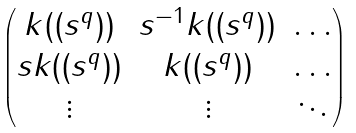Convert formula to latex. <formula><loc_0><loc_0><loc_500><loc_500>\begin{pmatrix} k ( ( s ^ { q } ) ) & s ^ { - 1 } k ( ( s ^ { q } ) ) & \hdots \\ s k ( ( s ^ { q } ) ) & k ( ( s ^ { q } ) ) & \hdots \\ \vdots & \vdots & \ddots \end{pmatrix}</formula> 